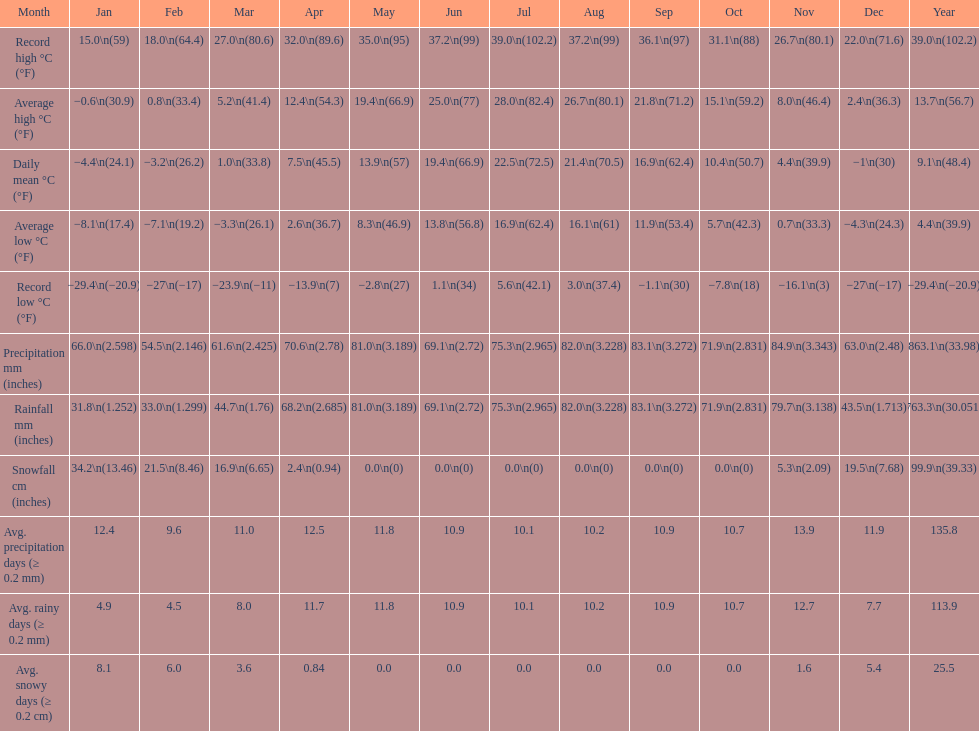Between january, october, and december, which month experienced the highest precipitation? October. 